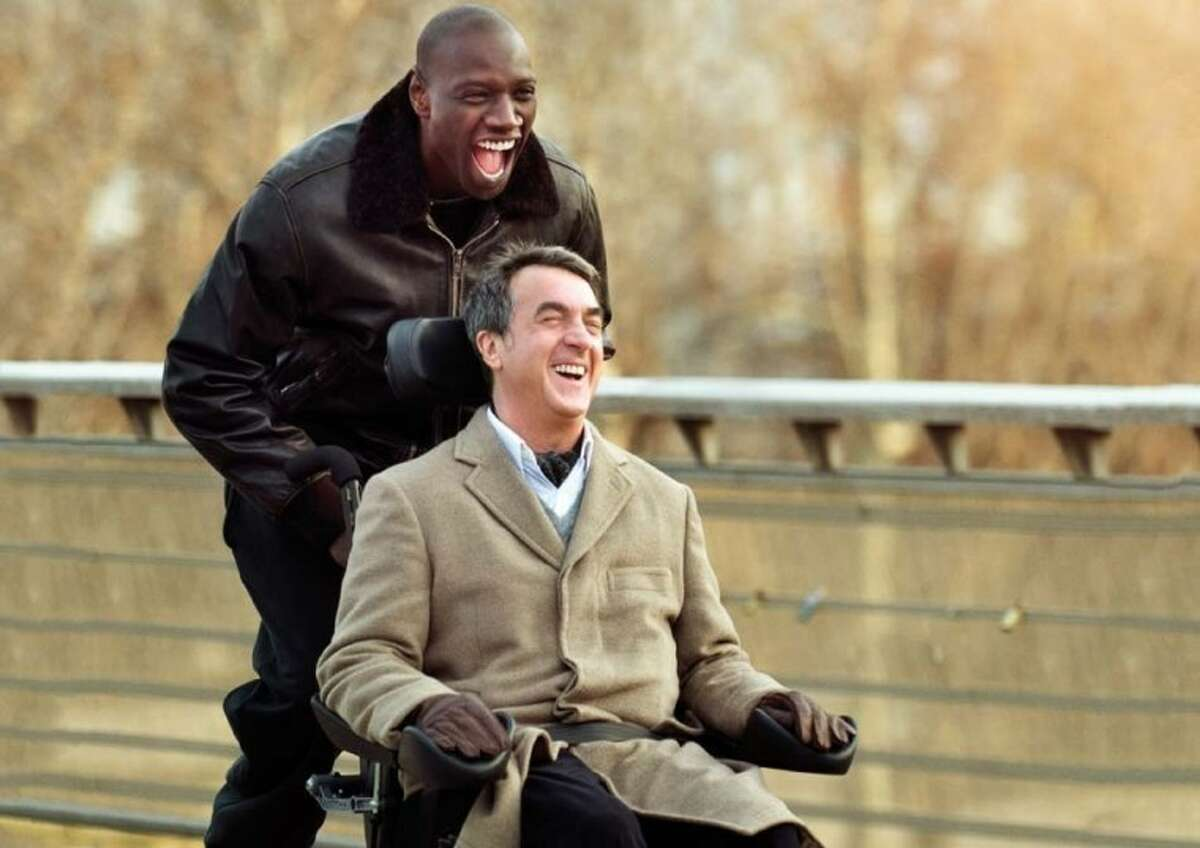What might have caused them to laugh in this scene? In this iconic scene, the characters are sharing a moment of genuine joy, likely sparked by one of their many adventures or mischievous acts. Their laughter is a celebration of the bond they've built, despite their contrasting backgrounds and circumstances. 